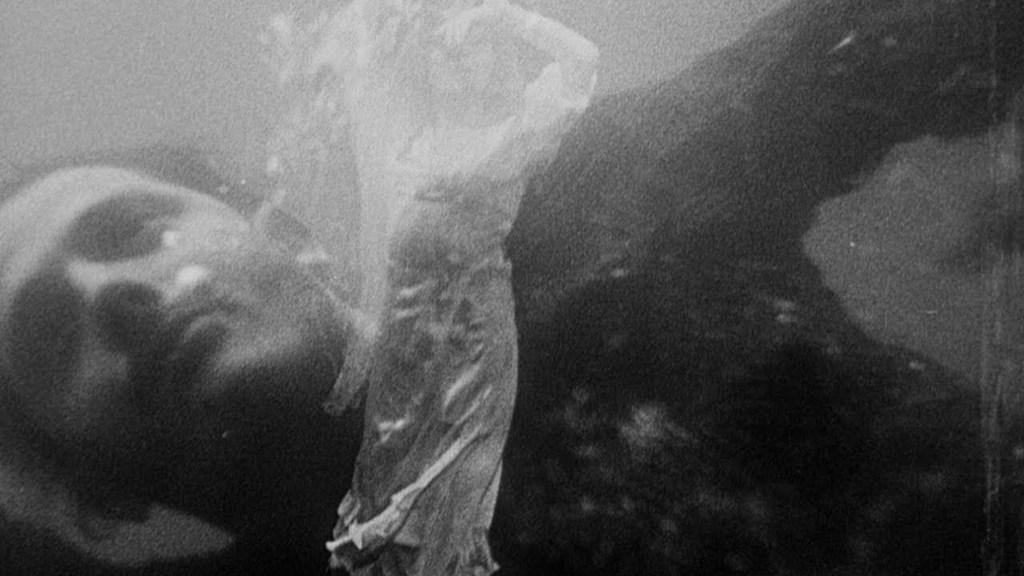What is the main subject of the image? There is a person in the water in the image. Can you describe the person's activity in the image? The person is in the water, but the specific activity cannot be determined from the provided fact. What is the setting of the image? The setting of the image is in or near water. What type of toy is the person holding in the water? There is no toy present in the image; it only shows a person in the water. 